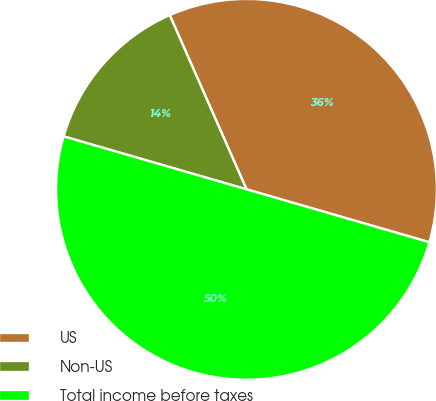Convert chart to OTSL. <chart><loc_0><loc_0><loc_500><loc_500><pie_chart><fcel>US<fcel>Non-US<fcel>Total income before taxes<nl><fcel>36.09%<fcel>13.91%<fcel>50.0%<nl></chart> 